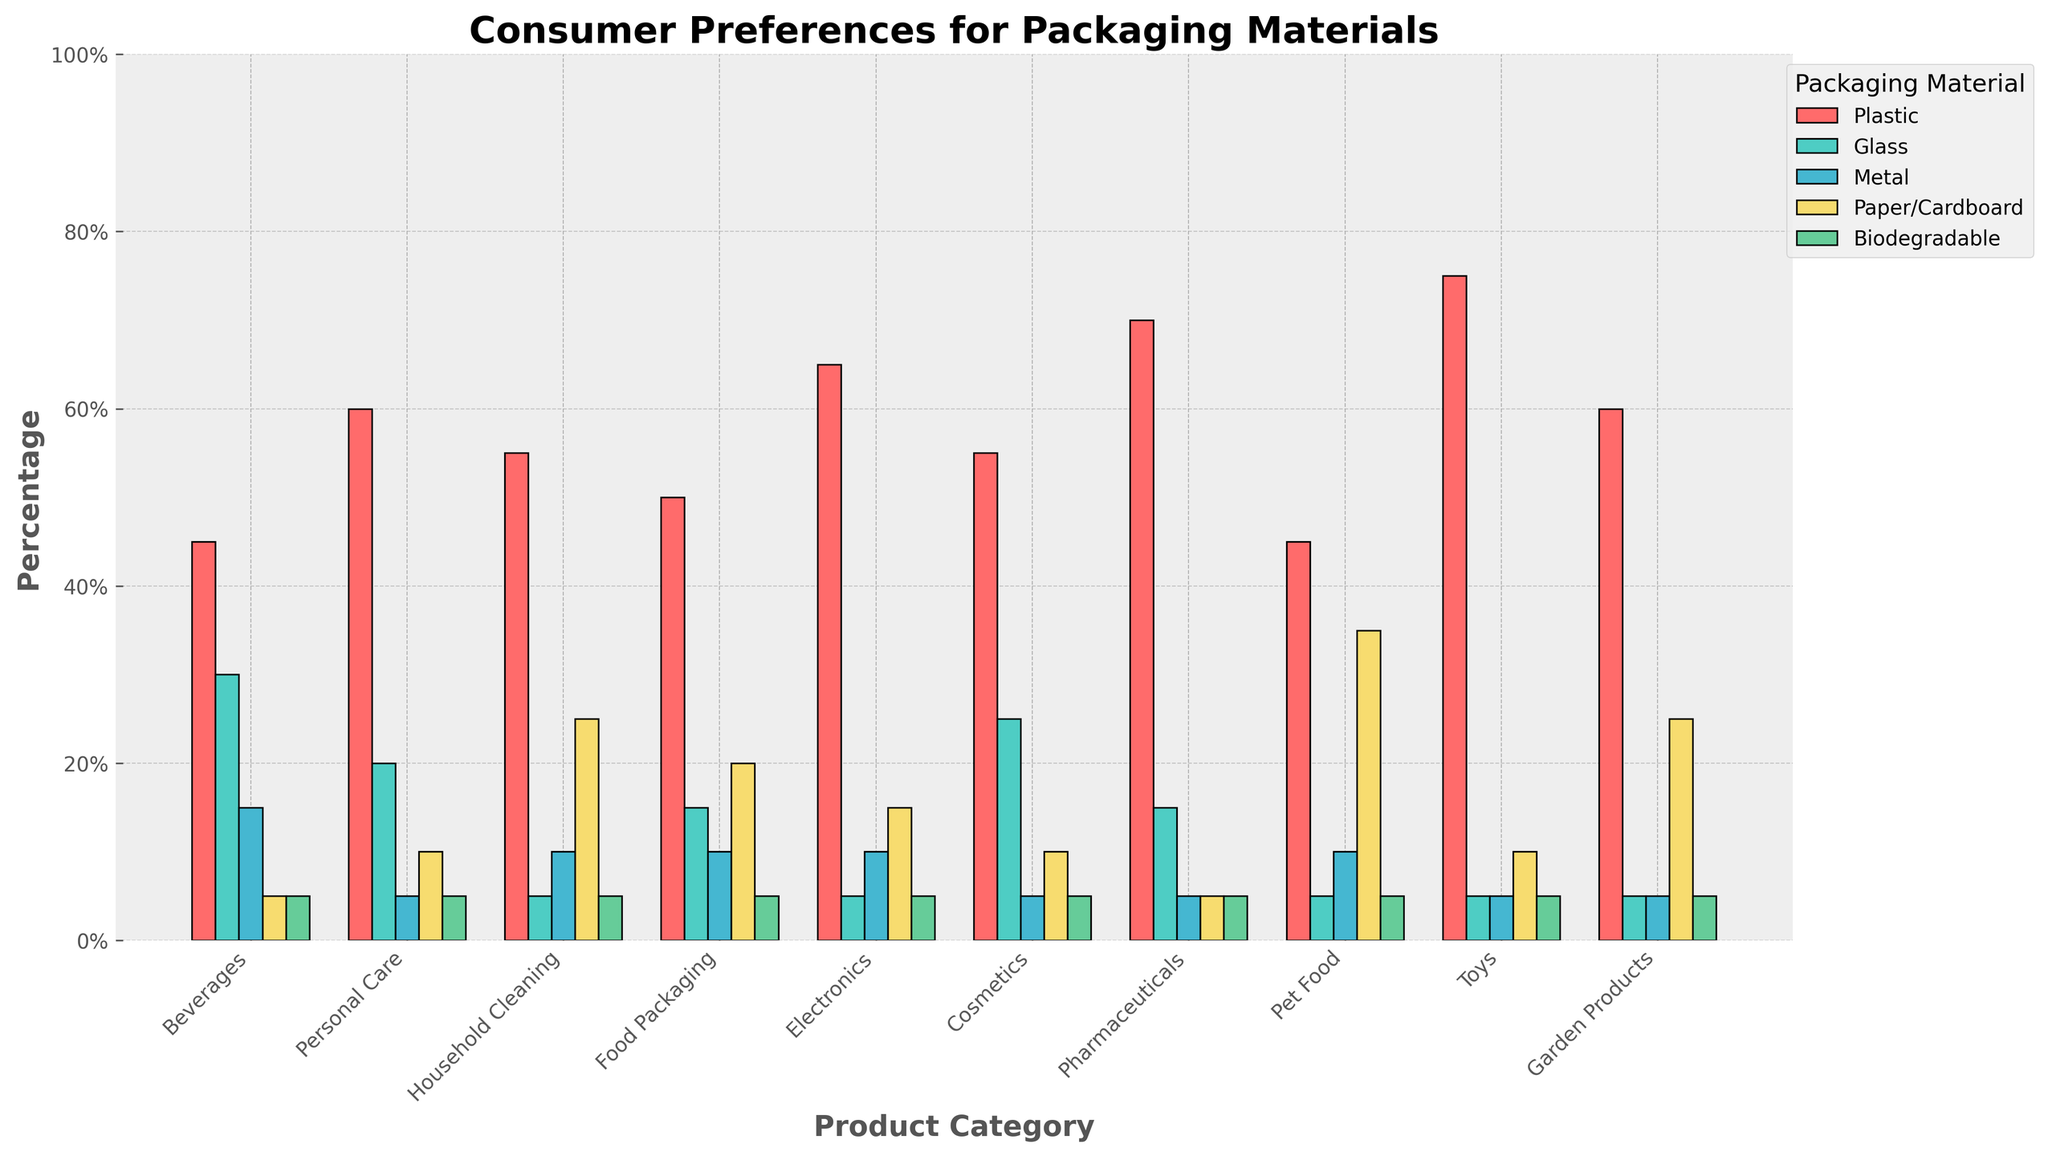Which product category has the highest preference for plastic packaging? Look at all the bars representing plastic packaging. Identify the category with the tallest bar. Toys has the tallest bar for plastic, indicating the highest preference.
Answer: Toys Which packaging material has the least preference for beverages? Locate the bars under the Beverages category and identify the one with the smallest height. Paper/Cardboard and Biodegradable both have the smallest bars under Beverages.
Answer: Paper/Cardboard, Biodegradable What is the total percentage preference for non-plastic materials in household cleaning? Sum the percentages of Glass, Metal, Paper/Cardboard, and Biodegradable for Household Cleaning. Glass (5) + Metal (10) + Paper/Cardboard (25) + Biodegradable (5) = 45%.
Answer: 45% How does the preference for metal compare between electronics and pharmaceuticals? Compare the heights of the bars representing metal packaging for Electronics and Pharmaceuticals. Both Electronics and Pharmaceuticals have the same height for Metal, 10 and 5, respectively.
Answer: Electronics > Pharmaceuticals What is the average preference for biodegradable packaging across all product categories? Sum the percentages of Biodegradable and then divide by the number of categories. (5+5+5+5+5+5+5+5+5+5)/10 = 5%.
Answer: 5% Which product category has the highest disparity between preference for plastic and preference for metal? Calculate the difference between the heights of the bars for Plastic and Metal in each category. Identify the category with the largest difference. Toys (Plastic 75, Metal 5, Difference = 70) shows the largest disparity.
Answer: Toys Compare the total preference for biodegradable packaging across all categories to the total preference for glass. Calculate the sum of preferences for Biodegradable and Glass across all categories and compare. Biodegradable (5*10 = 50), Glass (30+20+5+15+5+25+15+5+5+5 = 130).
Answer: Glass > Biodegradable Between beverages and cosmetics, which category shows higher preference for paper/cardboard packaging? Compare the heights of the bars representing Paper/Cardboard packaging for Beverages and Cosmetics. Beverages has a height of 5, while Cosmetics has a height of 10.
Answer: Cosmetics What is the combined percentage preference for plastic and glass for personal care products? Add the percentages for Plastic and Glass in the Personal Care category. Plastic (60) + Glass (20) = 80%.
Answer: 80% Is the preference for biodegradable packaging the same across all product categories? Look at the height of the bars representing Biodegradable packaging in every category. Every category has a bar height of 5 for Biodegradable packaging.
Answer: Yes 